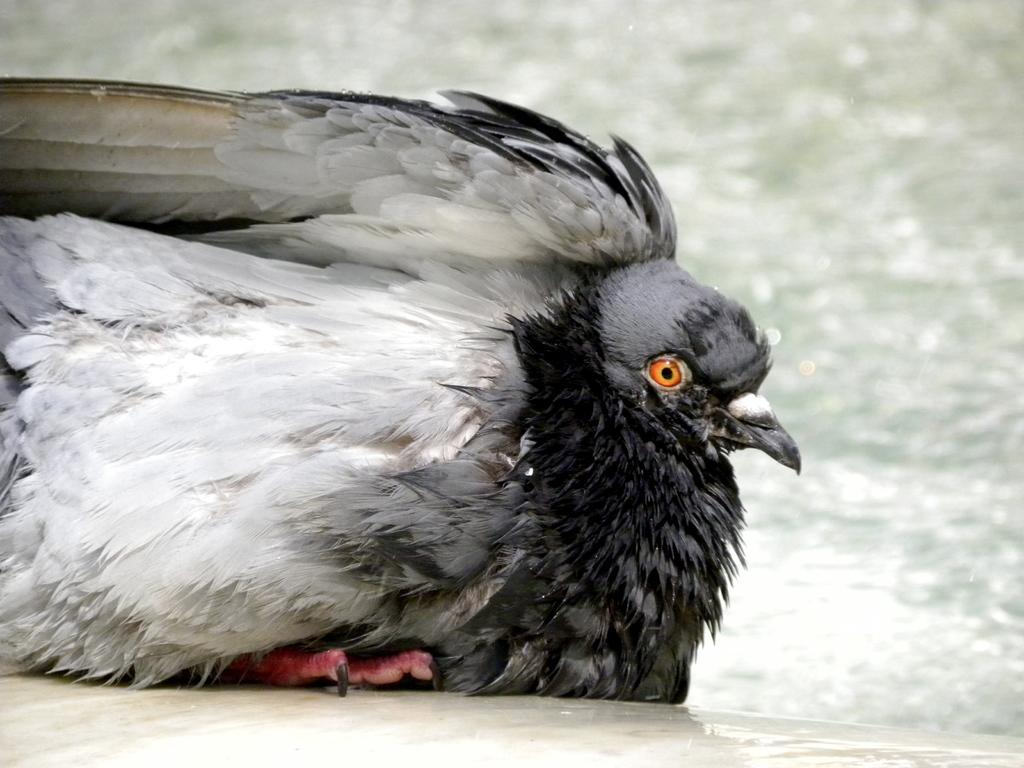What type of animal can be seen in the image? There is a bird in the image. What is visible beneath the bird? The ground is visible in the image. What can be seen in the distance behind the bird? There is water visible in the background of the image. What type of hate can be seen on the bird's face in the image? There is no indication of any emotion, such as hate, on the bird's face in the image. Additionally, birds do not have the ability to express emotions in the same way as humans. 